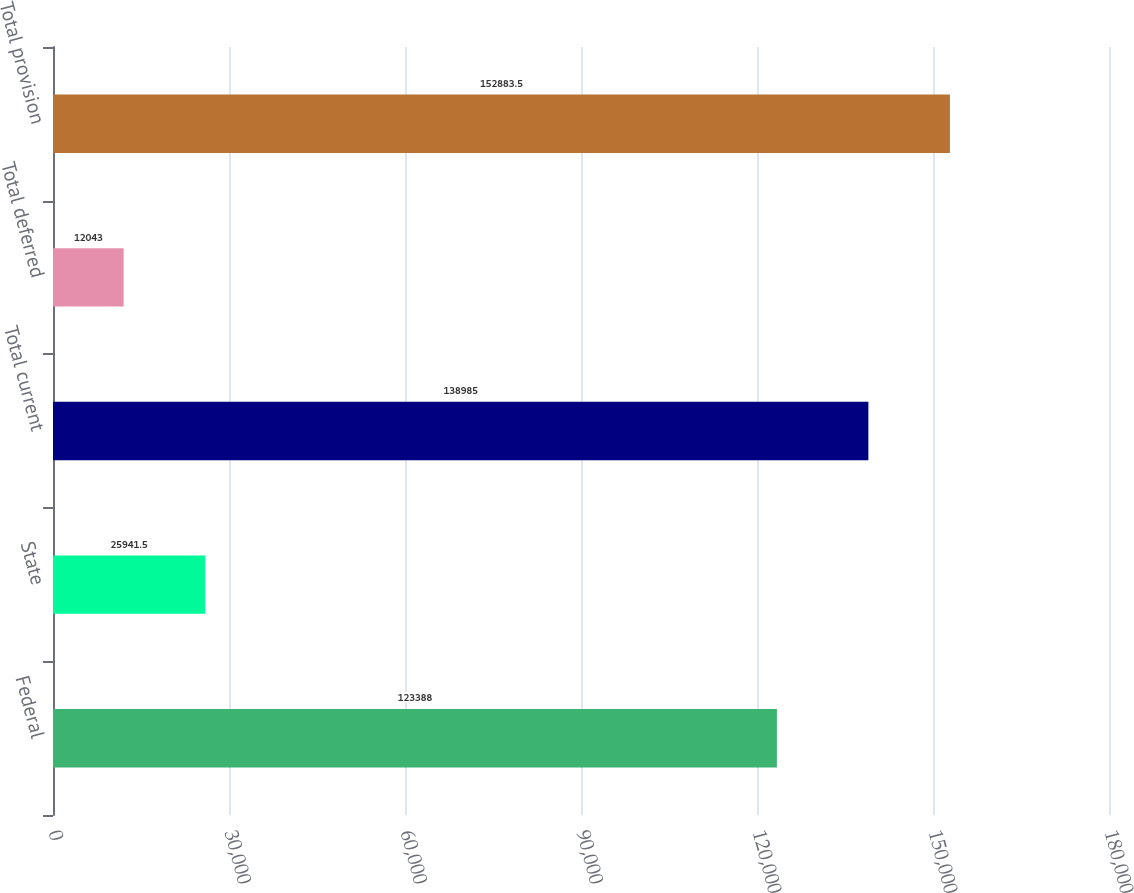Convert chart to OTSL. <chart><loc_0><loc_0><loc_500><loc_500><bar_chart><fcel>Federal<fcel>State<fcel>Total current<fcel>Total deferred<fcel>Total provision<nl><fcel>123388<fcel>25941.5<fcel>138985<fcel>12043<fcel>152884<nl></chart> 